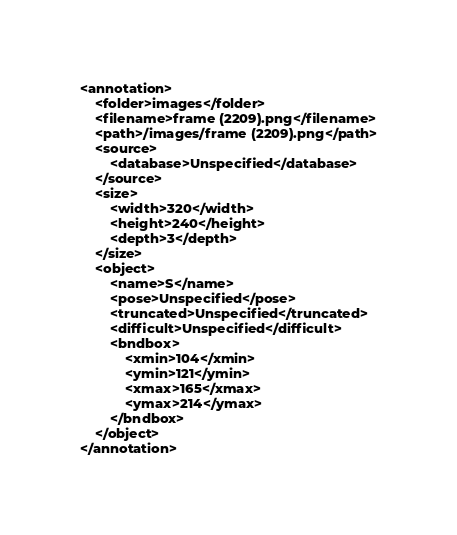Convert code to text. <code><loc_0><loc_0><loc_500><loc_500><_XML_><annotation>
	<folder>images</folder>
	<filename>frame (2209).png</filename>
	<path>/images/frame (2209).png</path>
	<source>
		<database>Unspecified</database>
	</source>
	<size>
		<width>320</width>
		<height>240</height>
		<depth>3</depth>
	</size>
	<object>
		<name>S</name>
		<pose>Unspecified</pose>
		<truncated>Unspecified</truncated>
		<difficult>Unspecified</difficult>
		<bndbox>
			<xmin>104</xmin>
			<ymin>121</ymin>
			<xmax>165</xmax>
			<ymax>214</ymax>
		</bndbox>
	</object>
</annotation></code> 